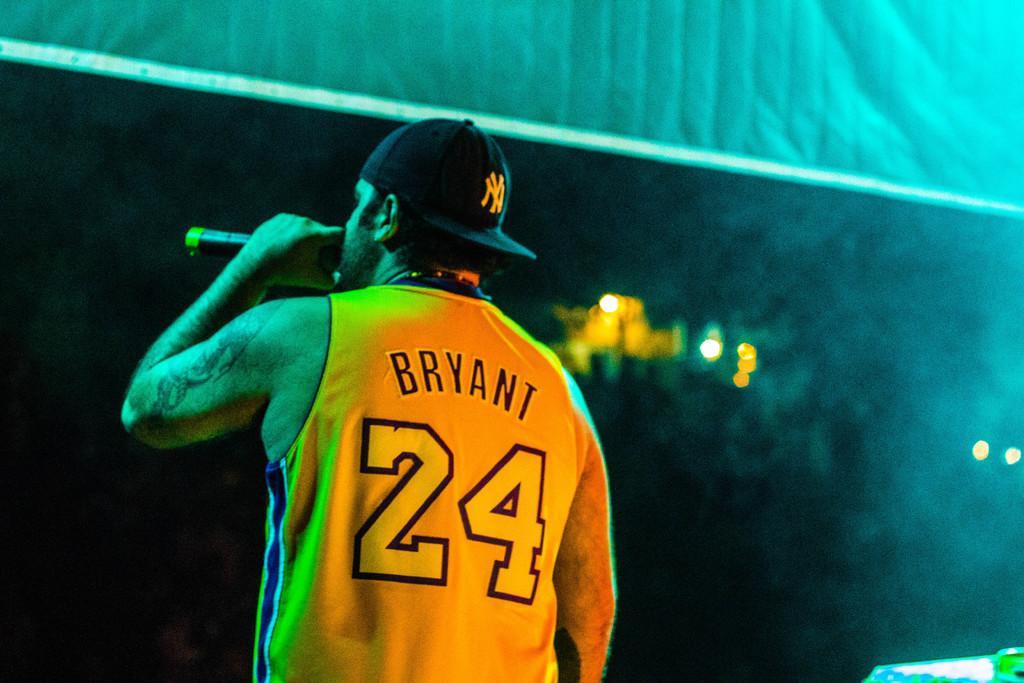How would you summarize this image in a sentence or two? In this picture there is a man standing and holding the microphone. At the back there are lights. At the top there might be a banner. At the bottom right there is an object on the table. 